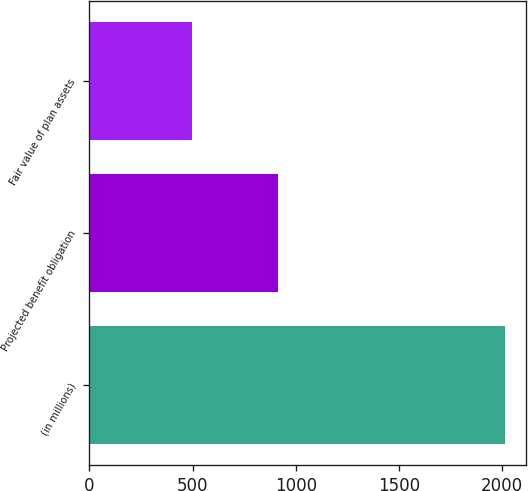Convert chart. <chart><loc_0><loc_0><loc_500><loc_500><bar_chart><fcel>(in millions)<fcel>Projected benefit obligation<fcel>Fair value of plan assets<nl><fcel>2015<fcel>912<fcel>497<nl></chart> 